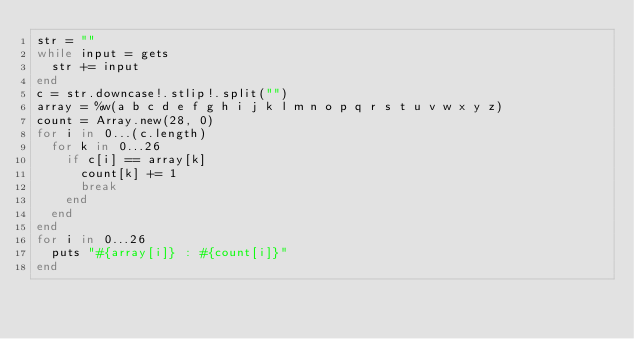Convert code to text. <code><loc_0><loc_0><loc_500><loc_500><_Ruby_>str = ""
while input = gets
	str += input
end
c = str.downcase!.stlip!.split("")
array = %w(a b c d e f g h i j k l m n o p q r s t u v w x y z)
count = Array.new(28, 0)
for i in 0...(c.length)
	for k in 0...26
		if c[i] == array[k]
			count[k] += 1
			break
		end
	end
end
for i in 0...26
	puts "#{array[i]} : #{count[i]}"
end</code> 